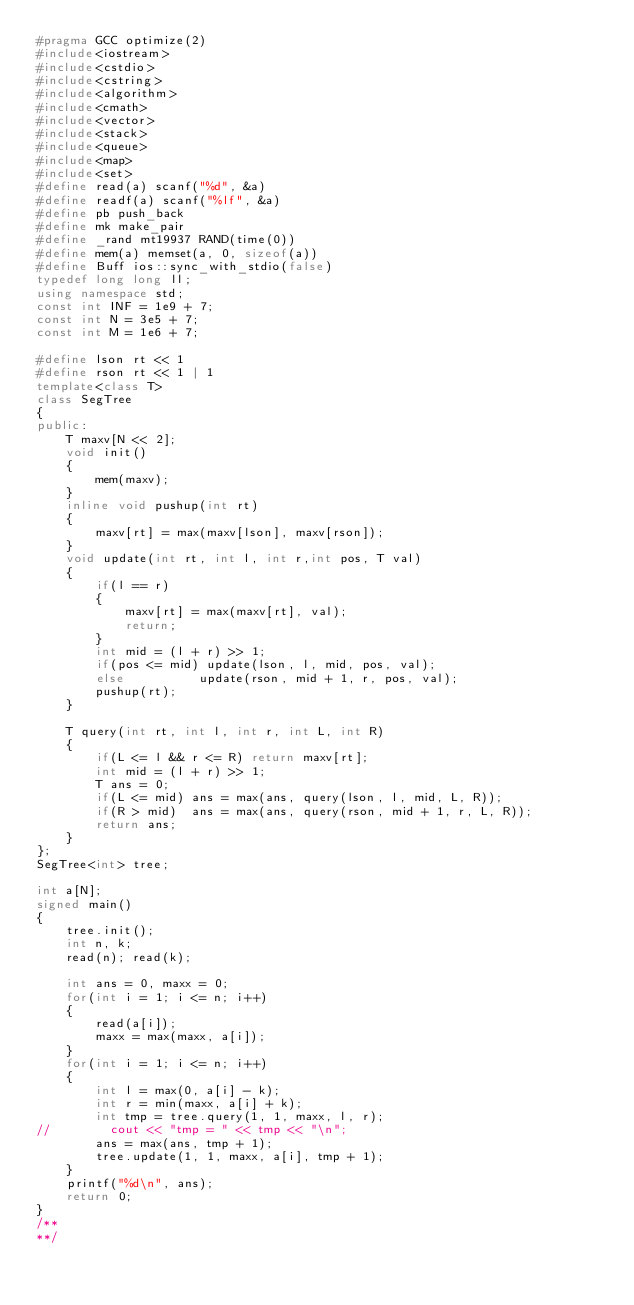<code> <loc_0><loc_0><loc_500><loc_500><_C++_>#pragma GCC optimize(2)
#include<iostream>
#include<cstdio>
#include<cstring>
#include<algorithm>
#include<cmath>
#include<vector>
#include<stack>
#include<queue>
#include<map>
#include<set>
#define read(a) scanf("%d", &a)
#define readf(a) scanf("%lf", &a)
#define pb push_back
#define mk make_pair
#define _rand mt19937 RAND(time(0))
#define mem(a) memset(a, 0, sizeof(a))
#define Buff ios::sync_with_stdio(false)
typedef long long ll;
using namespace std;
const int INF = 1e9 + 7;
const int N = 3e5 + 7;
const int M = 1e6 + 7;

#define lson rt << 1
#define rson rt << 1 | 1
template<class T>
class SegTree
{
public:
    T maxv[N << 2];
    void init()
    {
        mem(maxv);
    }
    inline void pushup(int rt)
    {
        maxv[rt] = max(maxv[lson], maxv[rson]);
    }
    void update(int rt, int l, int r,int pos, T val)
    {
        if(l == r)
        {
            maxv[rt] = max(maxv[rt], val);
            return;
        }
        int mid = (l + r) >> 1;
        if(pos <= mid) update(lson, l, mid, pos, val);
        else          update(rson, mid + 1, r, pos, val);
        pushup(rt);
    }

    T query(int rt, int l, int r, int L, int R)
    {
        if(L <= l && r <= R) return maxv[rt];
        int mid = (l + r) >> 1;
        T ans = 0;
        if(L <= mid) ans = max(ans, query(lson, l, mid, L, R));
        if(R > mid)  ans = max(ans, query(rson, mid + 1, r, L, R));
        return ans;
    }
};
SegTree<int> tree;

int a[N];
signed main()
{
    tree.init();
    int n, k;
    read(n); read(k);

    int ans = 0, maxx = 0;
    for(int i = 1; i <= n; i++)
    {
        read(a[i]);
        maxx = max(maxx, a[i]);
    }
    for(int i = 1; i <= n; i++)
    {
        int l = max(0, a[i] - k);
        int r = min(maxx, a[i] + k);
        int tmp = tree.query(1, 1, maxx, l, r);
//        cout << "tmp = " << tmp << "\n";
        ans = max(ans, tmp + 1);
        tree.update(1, 1, maxx, a[i], tmp + 1);
    }
    printf("%d\n", ans);
    return 0;
}
/**
**/

</code> 